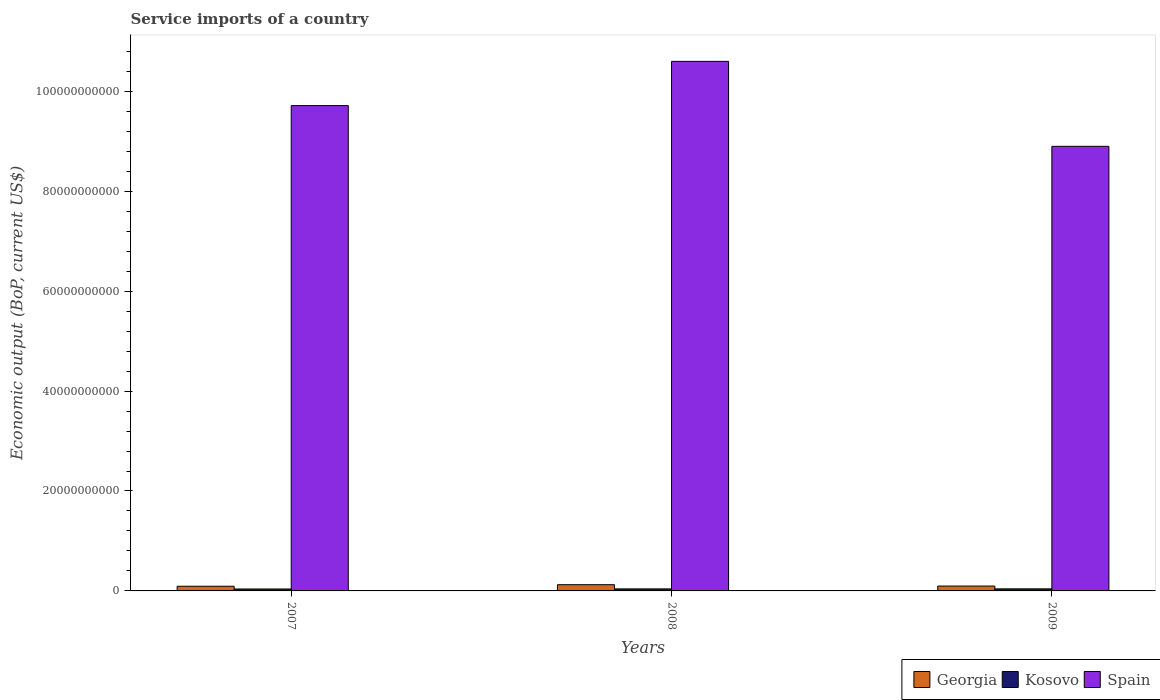How many different coloured bars are there?
Offer a very short reply. 3. How many groups of bars are there?
Give a very brief answer. 3. How many bars are there on the 3rd tick from the left?
Provide a succinct answer. 3. How many bars are there on the 3rd tick from the right?
Your response must be concise. 3. What is the service imports in Georgia in 2008?
Provide a succinct answer. 1.25e+09. Across all years, what is the maximum service imports in Kosovo?
Ensure brevity in your answer.  4.12e+08. Across all years, what is the minimum service imports in Spain?
Give a very brief answer. 8.90e+1. In which year was the service imports in Spain minimum?
Your answer should be very brief. 2009. What is the total service imports in Spain in the graph?
Your answer should be very brief. 2.92e+11. What is the difference between the service imports in Spain in 2007 and that in 2009?
Offer a very short reply. 8.15e+09. What is the difference between the service imports in Georgia in 2007 and the service imports in Spain in 2009?
Provide a short and direct response. -8.80e+1. What is the average service imports in Kosovo per year?
Make the answer very short. 4.01e+08. In the year 2008, what is the difference between the service imports in Spain and service imports in Kosovo?
Your response must be concise. 1.06e+11. In how many years, is the service imports in Spain greater than 4000000000 US$?
Keep it short and to the point. 3. What is the ratio of the service imports in Georgia in 2007 to that in 2009?
Offer a very short reply. 0.96. Is the service imports in Georgia in 2007 less than that in 2008?
Offer a terse response. Yes. What is the difference between the highest and the second highest service imports in Georgia?
Your response must be concise. 2.69e+08. What is the difference between the highest and the lowest service imports in Kosovo?
Your answer should be very brief. 2.75e+07. What does the 2nd bar from the left in 2007 represents?
Keep it short and to the point. Kosovo. How many years are there in the graph?
Your response must be concise. 3. What is the difference between two consecutive major ticks on the Y-axis?
Your response must be concise. 2.00e+1. Are the values on the major ticks of Y-axis written in scientific E-notation?
Your response must be concise. No. Does the graph contain any zero values?
Keep it short and to the point. No. Does the graph contain grids?
Give a very brief answer. No. What is the title of the graph?
Provide a short and direct response. Service imports of a country. Does "Botswana" appear as one of the legend labels in the graph?
Offer a very short reply. No. What is the label or title of the X-axis?
Provide a short and direct response. Years. What is the label or title of the Y-axis?
Your answer should be compact. Economic output (BoP, current US$). What is the Economic output (BoP, current US$) of Georgia in 2007?
Your answer should be very brief. 9.35e+08. What is the Economic output (BoP, current US$) of Kosovo in 2007?
Provide a succinct answer. 3.85e+08. What is the Economic output (BoP, current US$) in Spain in 2007?
Give a very brief answer. 9.71e+1. What is the Economic output (BoP, current US$) in Georgia in 2008?
Your answer should be compact. 1.25e+09. What is the Economic output (BoP, current US$) in Kosovo in 2008?
Provide a succinct answer. 4.06e+08. What is the Economic output (BoP, current US$) of Spain in 2008?
Your response must be concise. 1.06e+11. What is the Economic output (BoP, current US$) of Georgia in 2009?
Provide a succinct answer. 9.78e+08. What is the Economic output (BoP, current US$) of Kosovo in 2009?
Your answer should be very brief. 4.12e+08. What is the Economic output (BoP, current US$) in Spain in 2009?
Offer a terse response. 8.90e+1. Across all years, what is the maximum Economic output (BoP, current US$) in Georgia?
Your answer should be very brief. 1.25e+09. Across all years, what is the maximum Economic output (BoP, current US$) in Kosovo?
Provide a short and direct response. 4.12e+08. Across all years, what is the maximum Economic output (BoP, current US$) in Spain?
Provide a short and direct response. 1.06e+11. Across all years, what is the minimum Economic output (BoP, current US$) in Georgia?
Offer a very short reply. 9.35e+08. Across all years, what is the minimum Economic output (BoP, current US$) in Kosovo?
Offer a very short reply. 3.85e+08. Across all years, what is the minimum Economic output (BoP, current US$) in Spain?
Offer a terse response. 8.90e+1. What is the total Economic output (BoP, current US$) in Georgia in the graph?
Provide a short and direct response. 3.16e+09. What is the total Economic output (BoP, current US$) of Kosovo in the graph?
Provide a short and direct response. 1.20e+09. What is the total Economic output (BoP, current US$) of Spain in the graph?
Ensure brevity in your answer.  2.92e+11. What is the difference between the Economic output (BoP, current US$) in Georgia in 2007 and that in 2008?
Offer a very short reply. -3.11e+08. What is the difference between the Economic output (BoP, current US$) of Kosovo in 2007 and that in 2008?
Make the answer very short. -2.12e+07. What is the difference between the Economic output (BoP, current US$) of Spain in 2007 and that in 2008?
Your answer should be very brief. -8.86e+09. What is the difference between the Economic output (BoP, current US$) of Georgia in 2007 and that in 2009?
Provide a short and direct response. -4.29e+07. What is the difference between the Economic output (BoP, current US$) in Kosovo in 2007 and that in 2009?
Your answer should be compact. -2.75e+07. What is the difference between the Economic output (BoP, current US$) of Spain in 2007 and that in 2009?
Your answer should be very brief. 8.15e+09. What is the difference between the Economic output (BoP, current US$) in Georgia in 2008 and that in 2009?
Provide a short and direct response. 2.69e+08. What is the difference between the Economic output (BoP, current US$) of Kosovo in 2008 and that in 2009?
Your answer should be compact. -6.34e+06. What is the difference between the Economic output (BoP, current US$) in Spain in 2008 and that in 2009?
Make the answer very short. 1.70e+1. What is the difference between the Economic output (BoP, current US$) of Georgia in 2007 and the Economic output (BoP, current US$) of Kosovo in 2008?
Provide a succinct answer. 5.29e+08. What is the difference between the Economic output (BoP, current US$) in Georgia in 2007 and the Economic output (BoP, current US$) in Spain in 2008?
Offer a terse response. -1.05e+11. What is the difference between the Economic output (BoP, current US$) in Kosovo in 2007 and the Economic output (BoP, current US$) in Spain in 2008?
Provide a succinct answer. -1.06e+11. What is the difference between the Economic output (BoP, current US$) in Georgia in 2007 and the Economic output (BoP, current US$) in Kosovo in 2009?
Provide a succinct answer. 5.22e+08. What is the difference between the Economic output (BoP, current US$) in Georgia in 2007 and the Economic output (BoP, current US$) in Spain in 2009?
Provide a succinct answer. -8.80e+1. What is the difference between the Economic output (BoP, current US$) of Kosovo in 2007 and the Economic output (BoP, current US$) of Spain in 2009?
Provide a succinct answer. -8.86e+1. What is the difference between the Economic output (BoP, current US$) of Georgia in 2008 and the Economic output (BoP, current US$) of Kosovo in 2009?
Your answer should be compact. 8.34e+08. What is the difference between the Economic output (BoP, current US$) of Georgia in 2008 and the Economic output (BoP, current US$) of Spain in 2009?
Your response must be concise. -8.77e+1. What is the difference between the Economic output (BoP, current US$) of Kosovo in 2008 and the Economic output (BoP, current US$) of Spain in 2009?
Make the answer very short. -8.86e+1. What is the average Economic output (BoP, current US$) of Georgia per year?
Provide a short and direct response. 1.05e+09. What is the average Economic output (BoP, current US$) of Kosovo per year?
Make the answer very short. 4.01e+08. What is the average Economic output (BoP, current US$) in Spain per year?
Provide a short and direct response. 9.74e+1. In the year 2007, what is the difference between the Economic output (BoP, current US$) of Georgia and Economic output (BoP, current US$) of Kosovo?
Provide a short and direct response. 5.50e+08. In the year 2007, what is the difference between the Economic output (BoP, current US$) of Georgia and Economic output (BoP, current US$) of Spain?
Your answer should be compact. -9.62e+1. In the year 2007, what is the difference between the Economic output (BoP, current US$) of Kosovo and Economic output (BoP, current US$) of Spain?
Make the answer very short. -9.67e+1. In the year 2008, what is the difference between the Economic output (BoP, current US$) in Georgia and Economic output (BoP, current US$) in Kosovo?
Your response must be concise. 8.40e+08. In the year 2008, what is the difference between the Economic output (BoP, current US$) of Georgia and Economic output (BoP, current US$) of Spain?
Ensure brevity in your answer.  -1.05e+11. In the year 2008, what is the difference between the Economic output (BoP, current US$) of Kosovo and Economic output (BoP, current US$) of Spain?
Your answer should be very brief. -1.06e+11. In the year 2009, what is the difference between the Economic output (BoP, current US$) in Georgia and Economic output (BoP, current US$) in Kosovo?
Keep it short and to the point. 5.65e+08. In the year 2009, what is the difference between the Economic output (BoP, current US$) in Georgia and Economic output (BoP, current US$) in Spain?
Give a very brief answer. -8.80e+1. In the year 2009, what is the difference between the Economic output (BoP, current US$) in Kosovo and Economic output (BoP, current US$) in Spain?
Give a very brief answer. -8.86e+1. What is the ratio of the Economic output (BoP, current US$) in Georgia in 2007 to that in 2008?
Offer a terse response. 0.75. What is the ratio of the Economic output (BoP, current US$) in Kosovo in 2007 to that in 2008?
Make the answer very short. 0.95. What is the ratio of the Economic output (BoP, current US$) of Spain in 2007 to that in 2008?
Your answer should be compact. 0.92. What is the ratio of the Economic output (BoP, current US$) of Georgia in 2007 to that in 2009?
Make the answer very short. 0.96. What is the ratio of the Economic output (BoP, current US$) in Spain in 2007 to that in 2009?
Make the answer very short. 1.09. What is the ratio of the Economic output (BoP, current US$) of Georgia in 2008 to that in 2009?
Keep it short and to the point. 1.27. What is the ratio of the Economic output (BoP, current US$) in Kosovo in 2008 to that in 2009?
Provide a short and direct response. 0.98. What is the ratio of the Economic output (BoP, current US$) of Spain in 2008 to that in 2009?
Provide a short and direct response. 1.19. What is the difference between the highest and the second highest Economic output (BoP, current US$) of Georgia?
Offer a terse response. 2.69e+08. What is the difference between the highest and the second highest Economic output (BoP, current US$) of Kosovo?
Keep it short and to the point. 6.34e+06. What is the difference between the highest and the second highest Economic output (BoP, current US$) in Spain?
Ensure brevity in your answer.  8.86e+09. What is the difference between the highest and the lowest Economic output (BoP, current US$) in Georgia?
Your response must be concise. 3.11e+08. What is the difference between the highest and the lowest Economic output (BoP, current US$) of Kosovo?
Your answer should be compact. 2.75e+07. What is the difference between the highest and the lowest Economic output (BoP, current US$) in Spain?
Your response must be concise. 1.70e+1. 